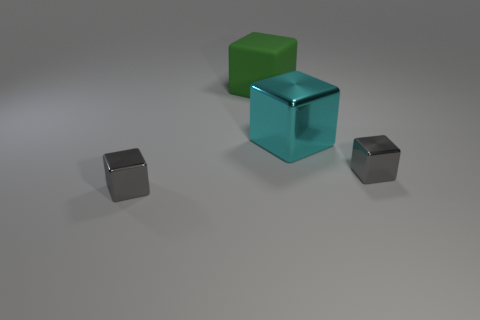Subtract all large cyan blocks. How many blocks are left? 3 Subtract 1 blocks. How many blocks are left? 3 Subtract all cyan cubes. How many cubes are left? 3 Subtract all brown blocks. Subtract all purple balls. How many blocks are left? 4 Add 2 small metal blocks. How many objects exist? 6 Add 3 tiny blocks. How many tiny blocks are left? 5 Add 3 tiny yellow rubber balls. How many tiny yellow rubber balls exist? 3 Subtract 0 green cylinders. How many objects are left? 4 Subtract all green matte cubes. Subtract all big cubes. How many objects are left? 1 